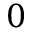<formula> <loc_0><loc_0><loc_500><loc_500>0</formula> 